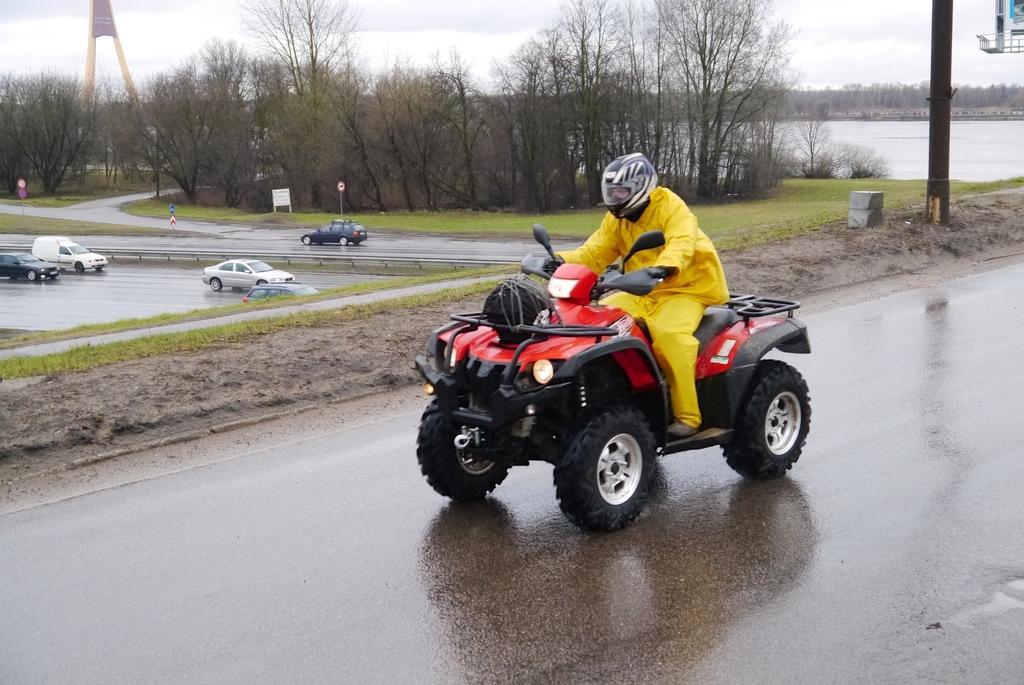Describe this image in one or two sentences. In this image we can see a person with helmet riding a vehicle. In the background we can also see some vehicles passing on the road. Image also consists of many trees. We can also see poles. In the background there is lake. Sky is also visible. 